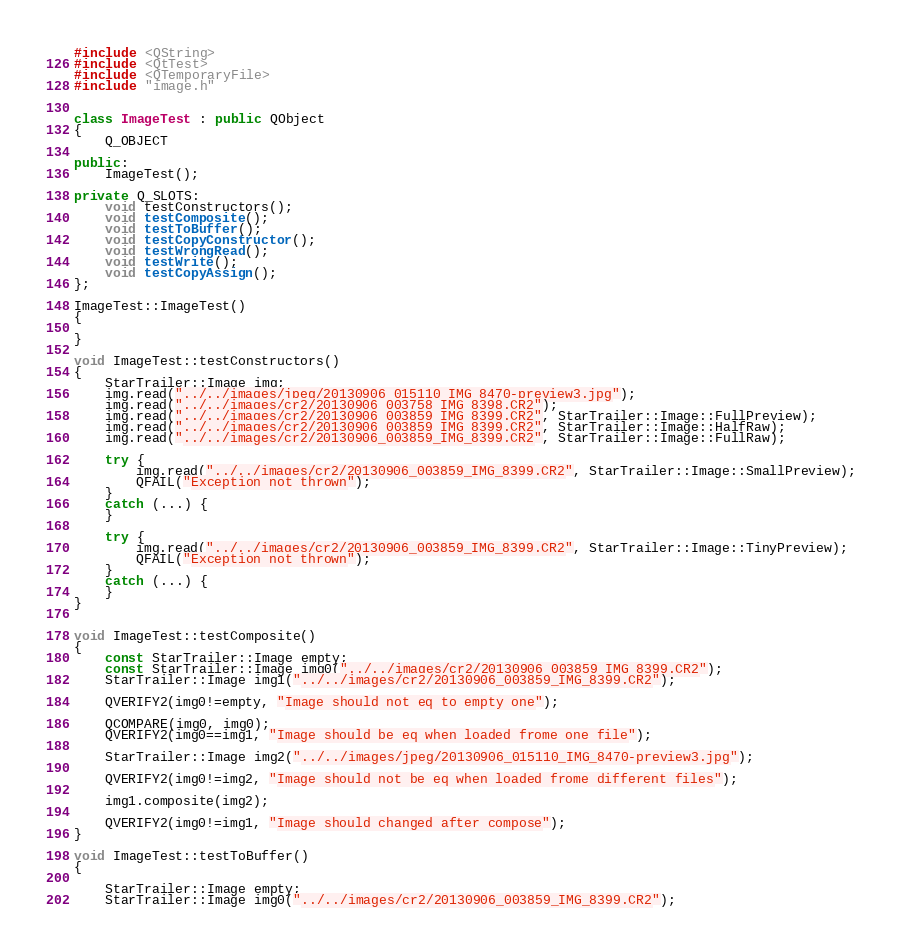<code> <loc_0><loc_0><loc_500><loc_500><_C++_>#include <QString>
#include <QtTest>
#include <QTemporaryFile>
#include "image.h"


class ImageTest : public QObject
{
    Q_OBJECT

public:
    ImageTest();

private Q_SLOTS:
    void testConstructors();
    void testComposite();
    void testToBuffer();
    void testCopyConstructor();
    void testWrongRead();
    void testWrite();
    void testCopyAssign();
};

ImageTest::ImageTest()
{

}

void ImageTest::testConstructors()
{
    StarTrailer::Image img;
    img.read("../../images/jpeg/20130906_015110_IMG_8470-preview3.jpg");
    img.read("../../images/cr2/20130906_003758_IMG_8398.CR2");
    img.read("../../images/cr2/20130906_003859_IMG_8399.CR2", StarTrailer::Image::FullPreview);
    img.read("../../images/cr2/20130906_003859_IMG_8399.CR2", StarTrailer::Image::HalfRaw);
    img.read("../../images/cr2/20130906_003859_IMG_8399.CR2", StarTrailer::Image::FullRaw);

    try {
        img.read("../../images/cr2/20130906_003859_IMG_8399.CR2", StarTrailer::Image::SmallPreview);
        QFAIL("Exception not thrown");
    }
    catch (...) {
    }

    try {
        img.read("../../images/cr2/20130906_003859_IMG_8399.CR2", StarTrailer::Image::TinyPreview);
        QFAIL("Exception not thrown");
    }
    catch (...) {
    }
}


void ImageTest::testComposite()
{
    const StarTrailer::Image empty;
    const StarTrailer::Image img0("../../images/cr2/20130906_003859_IMG_8399.CR2");
    StarTrailer::Image img1("../../images/cr2/20130906_003859_IMG_8399.CR2");

    QVERIFY2(img0!=empty, "Image should not eq to empty one");

    QCOMPARE(img0, img0);
    QVERIFY2(img0==img1, "Image should be eq when loaded frome one file");

    StarTrailer::Image img2("../../images/jpeg/20130906_015110_IMG_8470-preview3.jpg");

    QVERIFY2(img0!=img2, "Image should not be eq when loaded frome different files");

    img1.composite(img2);

    QVERIFY2(img0!=img1, "Image should changed after compose");
}

void ImageTest::testToBuffer()
{

    StarTrailer::Image empty;
    StarTrailer::Image img0("../../images/cr2/20130906_003859_IMG_8399.CR2");</code> 